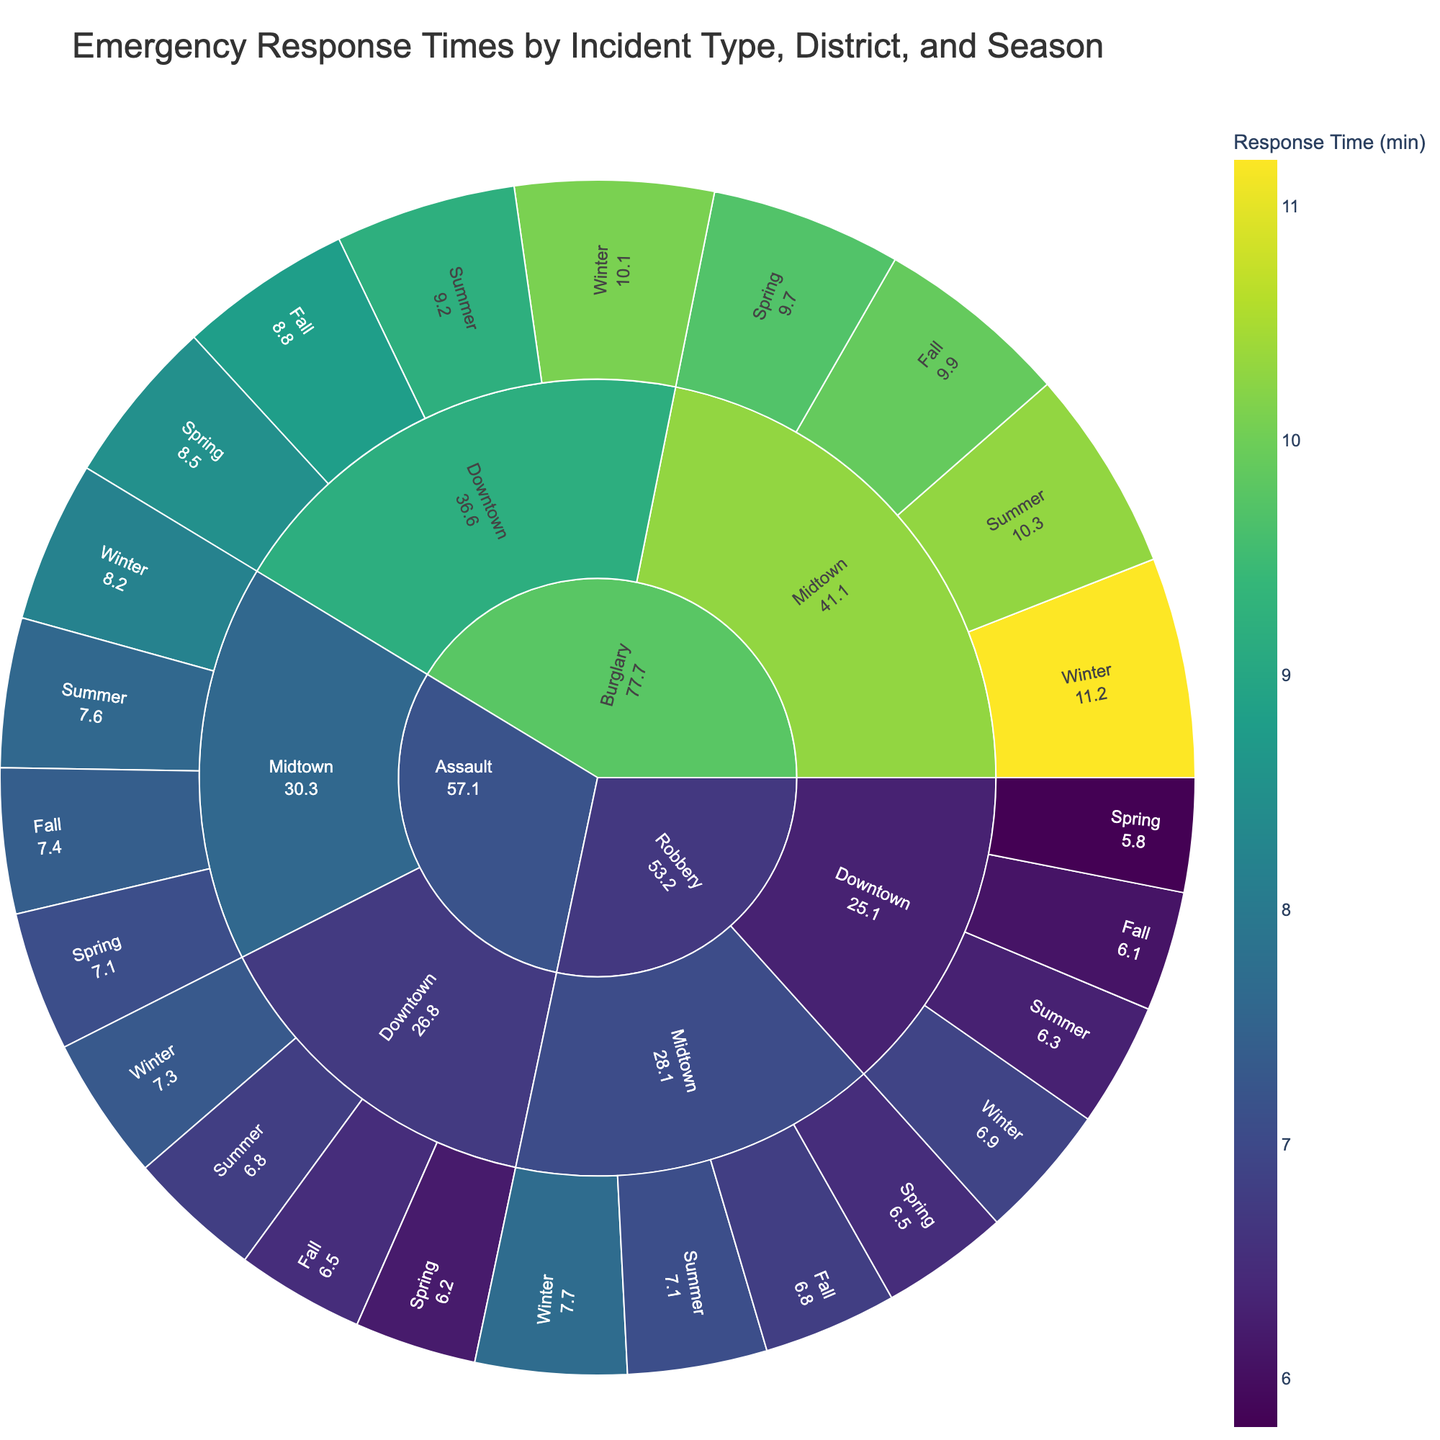What is the title of the plot? The title is prominently displayed at the top of the figure.
Answer: Emergency Response Times by Incident Type, District, and Season Which incident type has the highest average response time overall? By comparing the average response times across Burglary, Assault, and Robbery segments, Burglary shows higher values.
Answer: Burglary What are the response times for Robbery incidents in Downtown during Winter? Locate the Robbery segment, navigate to Downtown, and then find Winter to see the response time.
Answer: 6.9 Which district has the longer response times for Burglary incidents, Downtown or Midtown? By comparing the average response times for Burglary in Downtown and Midtown, Midtown has higher values.
Answer: Midtown How does the seasonal response time for Assault in Downtown vary? Examine the Assault -> Downtown pathway and compare response times for Spring, Summer, Fall, and Winter.
Answer: Spring: 6.2, Summer: 6.8, Fall: 6.5, Winter: 7.3 What is the average response time for Burglary incidents in Winter across both districts? Combine Burglary -> Winter values for Downtown (10.1) and Midtown (11.2) and find the average: (10.1 + 11.2) / 2.
Answer: 10.65 Which season has the quickest response time for Robbery in Midtown? Navigate through Robbery -> Midtown and compare Spring, Summer, Fall, and Winter values.
Answer: Spring Between Assault and Robbery in Downtown, which incident type has a quicker average response time in Fall? Compare the Fall response times for Assault (6.5) and Robbery (6.1) in Downtown.
Answer: Robbery How do the average response times for Assault vary between Downtown and Midtown? Compare the average response times for Assault incidents in Downtown and Midtown across all seasons. Downtown: (6.2+6.8+6.5+7.3)/4 = 6.7; Midtown: (7.1+7.6+7.4+8.2)/4 = 7.575.
Answer: Downtown: 6.7, Midtown: 7.575 